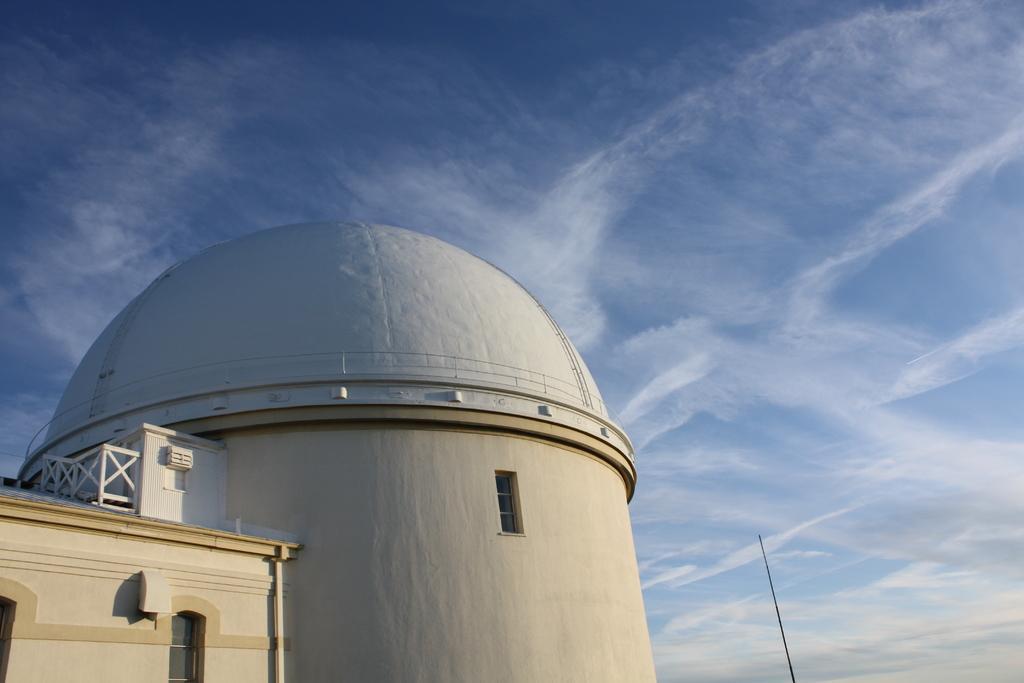Could you give a brief overview of what you see in this image? This picture is clicked outside. On the left we can see the buildings and we can see the windows of the building and we can see the metal rods and a dome is attached to the building. In the background there is a sky. 